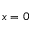<formula> <loc_0><loc_0><loc_500><loc_500>x = 0</formula> 